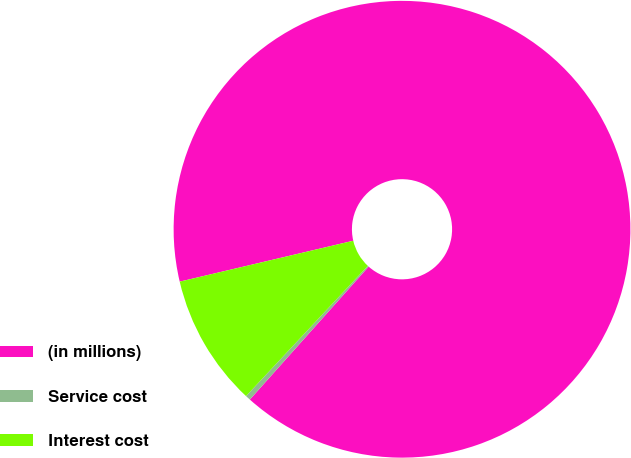Convert chart. <chart><loc_0><loc_0><loc_500><loc_500><pie_chart><fcel>(in millions)<fcel>Service cost<fcel>Interest cost<nl><fcel>90.29%<fcel>0.36%<fcel>9.35%<nl></chart> 